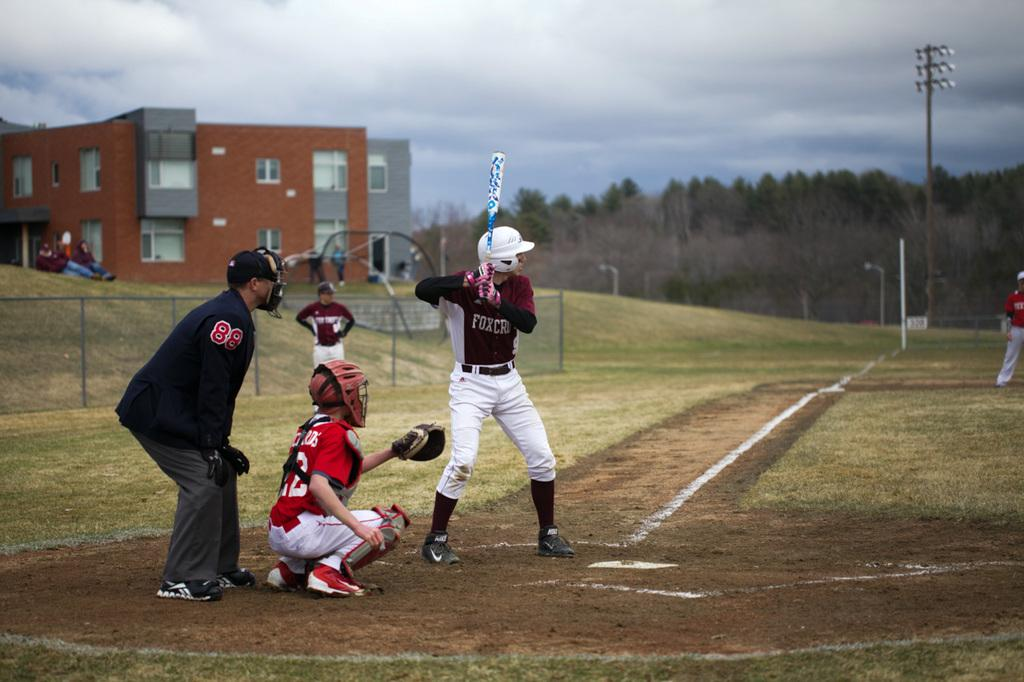<image>
Write a terse but informative summary of the picture. A baseball player up to bat at a baseball game with a burgundy and white shirt on with the word FOX on the front. 